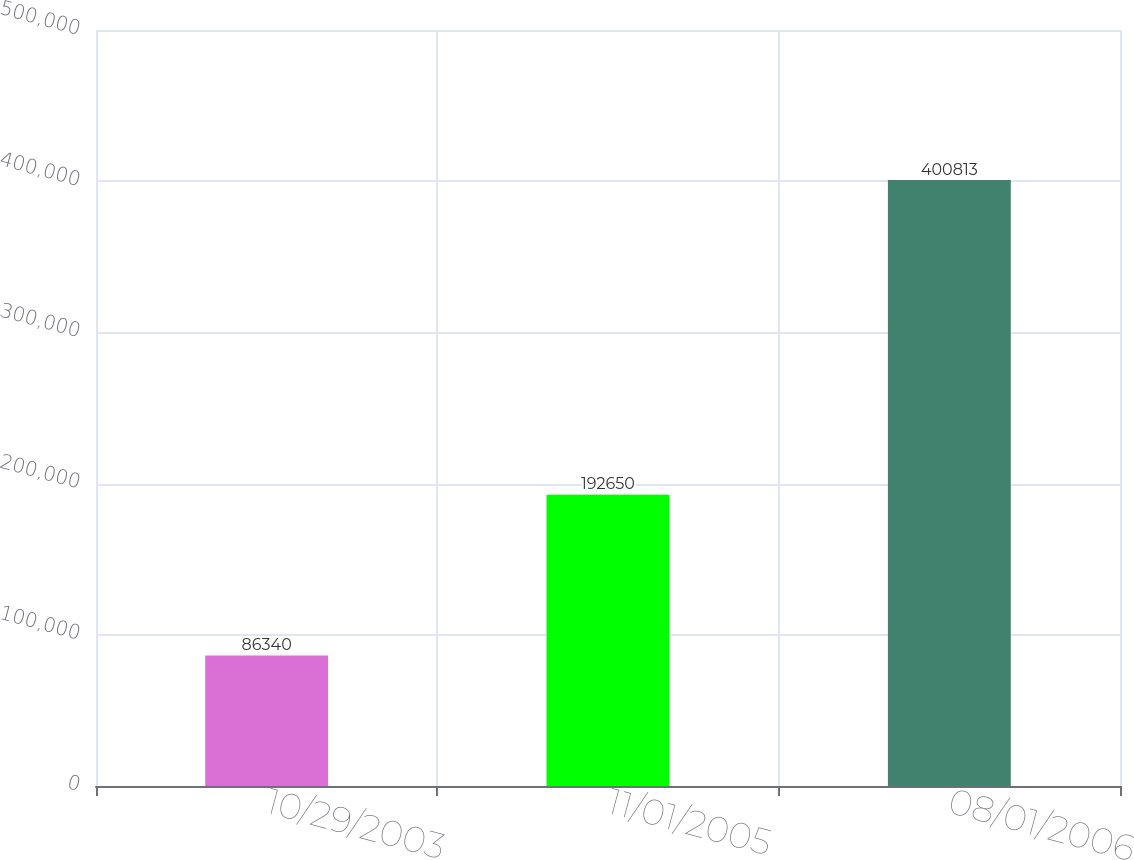Convert chart. <chart><loc_0><loc_0><loc_500><loc_500><bar_chart><fcel>10/29/2003<fcel>11/01/2005<fcel>08/01/2006<nl><fcel>86340<fcel>192650<fcel>400813<nl></chart> 